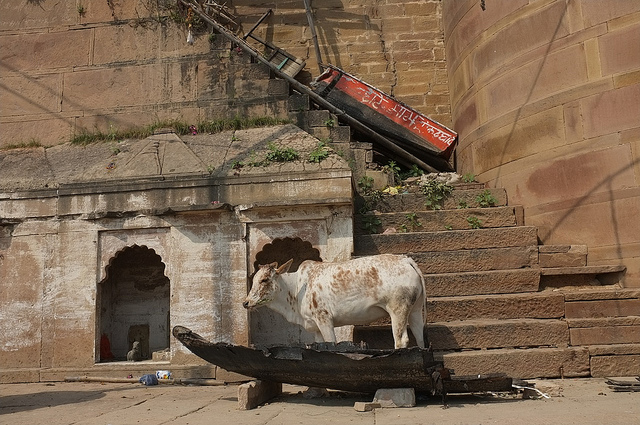How does the background contribute to the overall atmosphere of the scene? The rustic architecture and the worn steps in the background, coupled with the casual presence of a boat, contribute to a sense of faded grandeur and timeless continuity in this scene. 